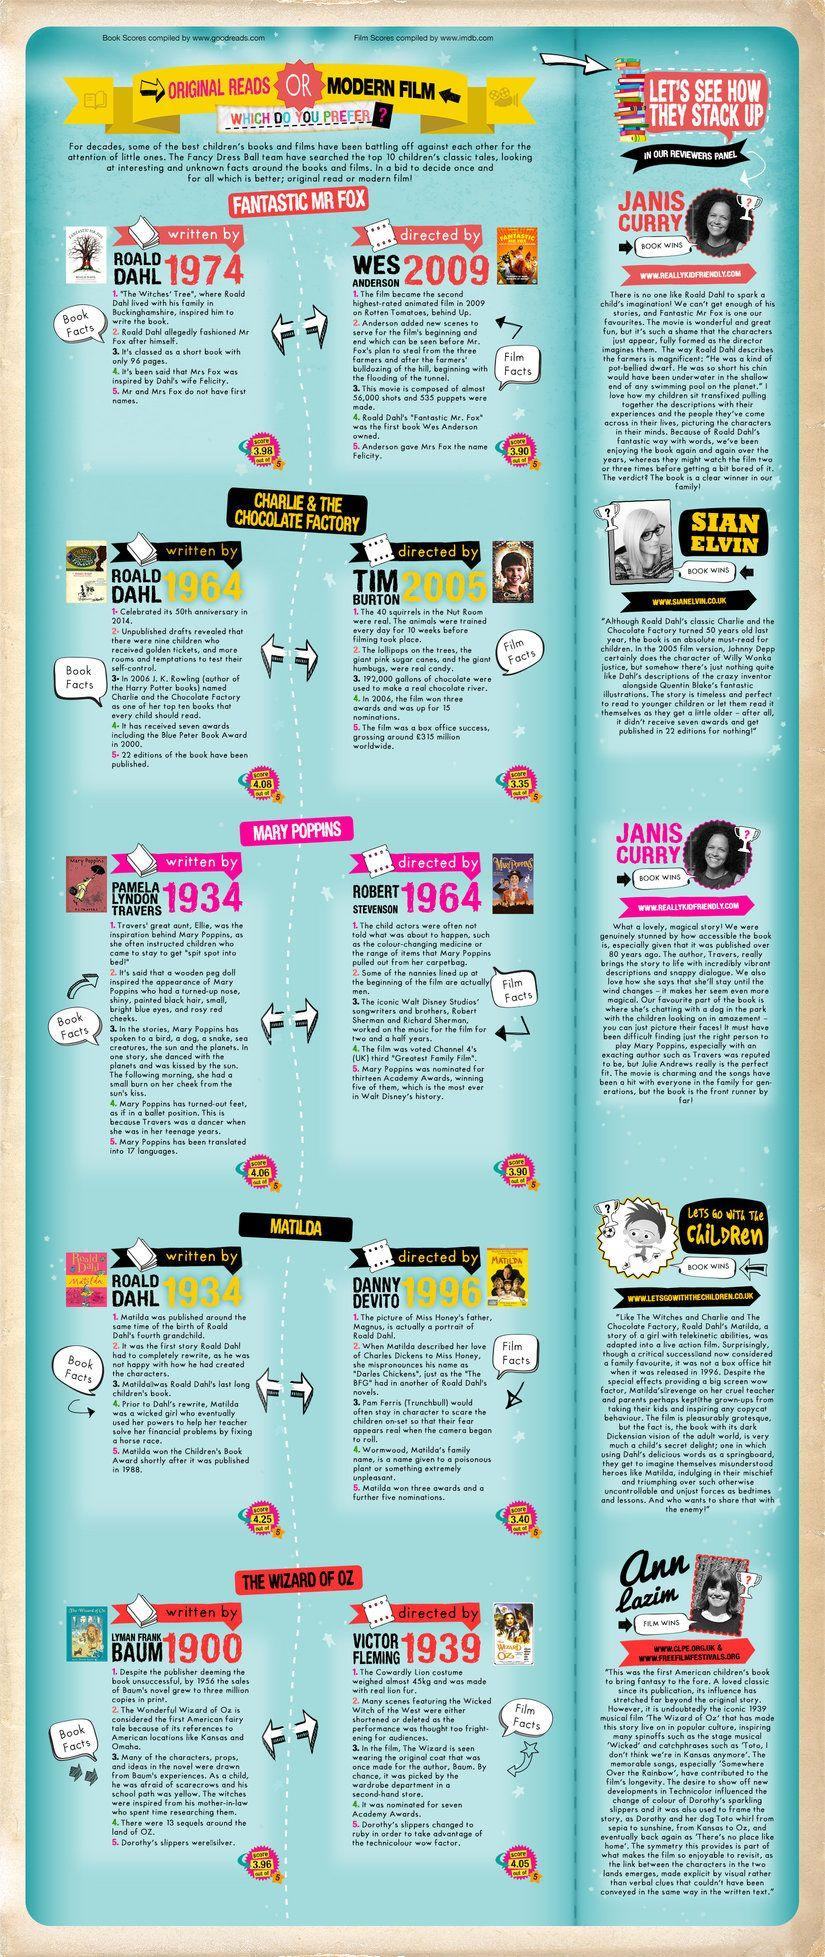Point out several critical features in this image. The book 'Mary Poppins' was published in 1934. The movie "Fantastic Mr. Fox" was directed by Wes Anderson. Lyman Frank Baum is the author of "The Wizard of Oz. The movie "Charlie and the Chocolate Factory," directed by Tim Burton in 2005, is a question. The worldwide box office collection of the movie "Charlie & the Chocolate Factory" is 315 million pounds. 